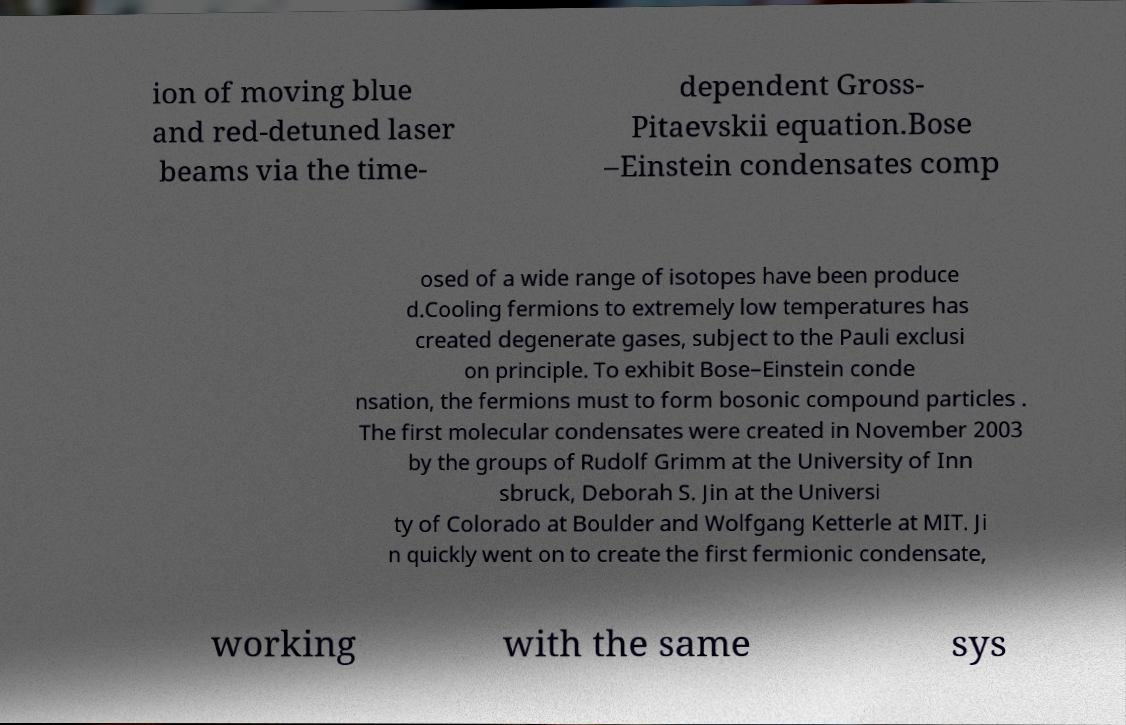What messages or text are displayed in this image? I need them in a readable, typed format. ion of moving blue and red-detuned laser beams via the time- dependent Gross- Pitaevskii equation.Bose –Einstein condensates comp osed of a wide range of isotopes have been produce d.Cooling fermions to extremely low temperatures has created degenerate gases, subject to the Pauli exclusi on principle. To exhibit Bose–Einstein conde nsation, the fermions must to form bosonic compound particles . The first molecular condensates were created in November 2003 by the groups of Rudolf Grimm at the University of Inn sbruck, Deborah S. Jin at the Universi ty of Colorado at Boulder and Wolfgang Ketterle at MIT. Ji n quickly went on to create the first fermionic condensate, working with the same sys 